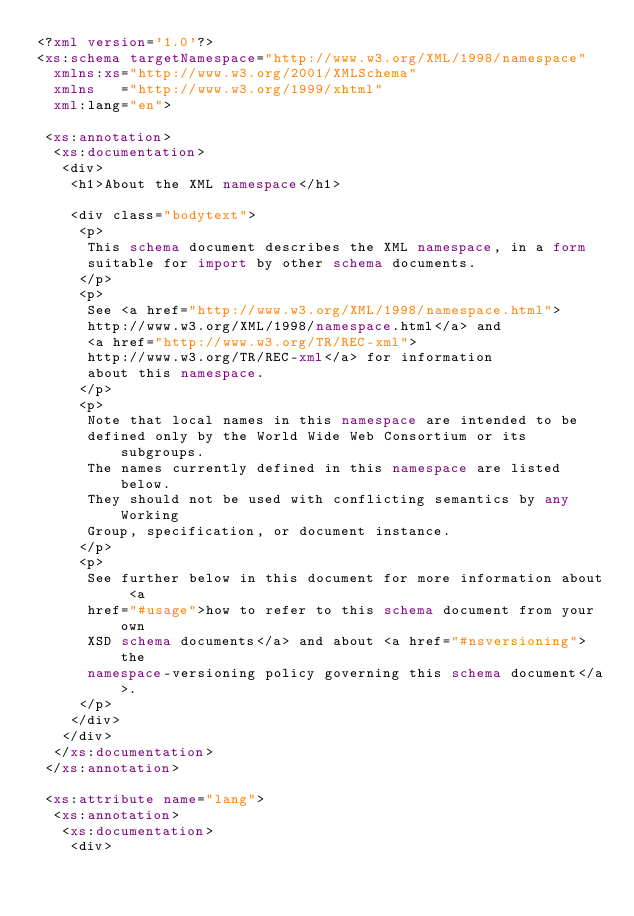<code> <loc_0><loc_0><loc_500><loc_500><_XML_><?xml version='1.0'?>
<xs:schema targetNamespace="http://www.w3.org/XML/1998/namespace" 
  xmlns:xs="http://www.w3.org/2001/XMLSchema" 
  xmlns   ="http://www.w3.org/1999/xhtml"
  xml:lang="en">

 <xs:annotation>
  <xs:documentation>
   <div>
    <h1>About the XML namespace</h1>

    <div class="bodytext">
     <p>
      This schema document describes the XML namespace, in a form
      suitable for import by other schema documents.
     </p>
     <p>
      See <a href="http://www.w3.org/XML/1998/namespace.html">
      http://www.w3.org/XML/1998/namespace.html</a> and
      <a href="http://www.w3.org/TR/REC-xml">
      http://www.w3.org/TR/REC-xml</a> for information 
      about this namespace.
     </p>
     <p>
      Note that local names in this namespace are intended to be
      defined only by the World Wide Web Consortium or its subgroups.
      The names currently defined in this namespace are listed below.
      They should not be used with conflicting semantics by any Working
      Group, specification, or document instance.
     </p>
     <p>   
      See further below in this document for more information about <a
      href="#usage">how to refer to this schema document from your own
      XSD schema documents</a> and about <a href="#nsversioning">the
      namespace-versioning policy governing this schema document</a>.
     </p>
    </div>
   </div>
  </xs:documentation>
 </xs:annotation>

 <xs:attribute name="lang">
  <xs:annotation>
   <xs:documentation>
    <div></code> 